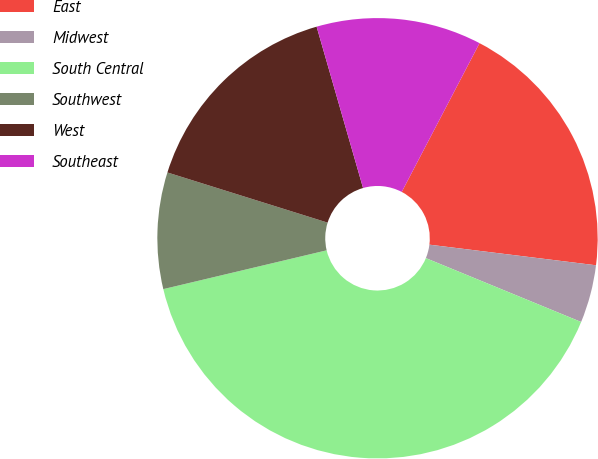Convert chart to OTSL. <chart><loc_0><loc_0><loc_500><loc_500><pie_chart><fcel>East<fcel>Midwest<fcel>South Central<fcel>Southwest<fcel>West<fcel>Southeast<nl><fcel>19.29%<fcel>4.25%<fcel>40.08%<fcel>8.54%<fcel>15.71%<fcel>12.13%<nl></chart> 